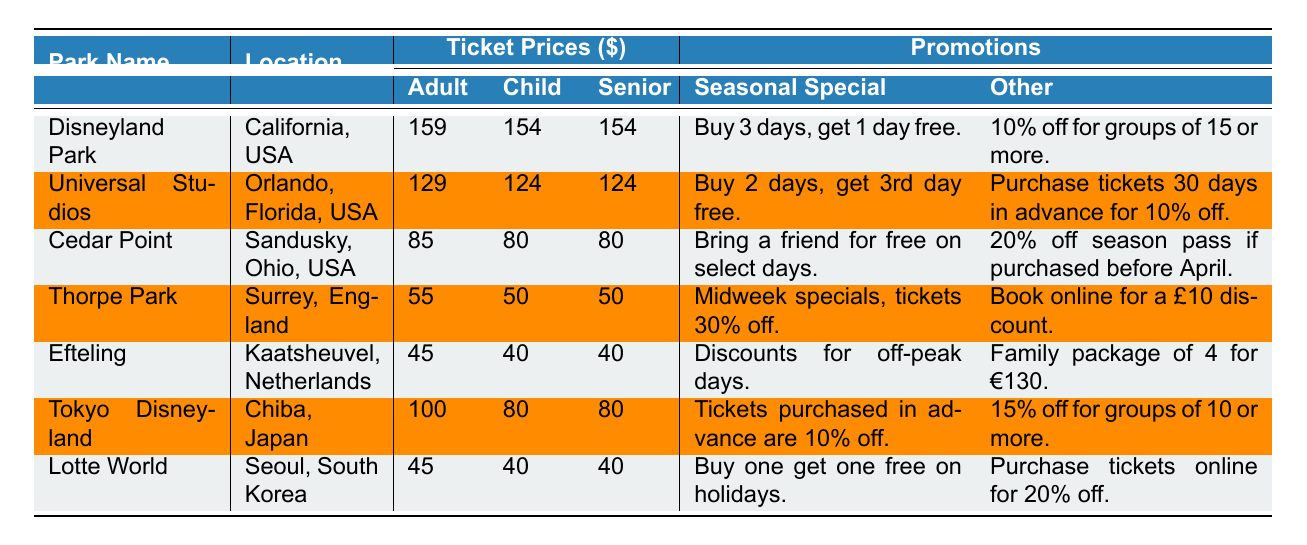What is the highest ticket price for an adult ticket? By looking at the column for adult ticket prices, Disneyland Park has the highest price of $159.
Answer: $159 Which park offers a seasonal special that allows you to buy two days and get a third day free? The table shows that Universal Studios has a seasonal special for buying two days and getting a third day free.
Answer: Universal Studios What is the combined ticket price for an adult and a child at Cedar Point? Cedar Point's adult ticket price is $85, and the child ticket price is $80. Adding these two amounts ($85 + $80) gives a total of $165.
Answer: $165 Is there a promotion for seniors at Lotte World? The table indicates that Lotte World has not specified any promotion specifically for seniors.
Answer: No Which park offers the most discounts for advance purchases? Analyzing the promotions for each park, Universal Studios and Tokyo Disneyland both have promotions related to advance purchases, but Universal Studios also includes early bird discounts for 30 days in advance, making it the park with the most associated discounts.
Answer: Universal Studios What is the total ticket price for a family of four (2 adults and 2 children) at Efteling? Efteling charges $45 for adults and $40 for children. Thus, the total ticket price is calculated as (2 * $45) + (2 * $40) = $90 + $80 = $170.
Answer: $170 Which park has the lowest combined ticket price for an adult and senior? The lowest ticket prices for adult and senior at Thorpe Park are $55 and $50 respectively. Adding these gives $55 + $50 = $105, which is lower than other parks' combinations.
Answer: Thorpe Park Does Tokyo Disneyland provide any group discounts? Yes, the table mentions that Tokyo Disneyland offers a 15% discount for groups of 10 or more.
Answer: Yes Which park located in the Netherlands offers discounts for off-peak days? Efteling, located in Kaatsheuvel, Netherlands, provides discounts for off-peak days as indicated in the promotions.
Answer: Efteling Compute the average ticket price for a child across all parks. The child prices are as follows: $154, $124, $80, $50, $40, $80, and $40. Summing these gives $154 + $124 + $80 + $50 + $40 + $80 + $40 = $568, and with 7 parks, the average is $568 / 7 = approximately $81.14.
Answer: $81.14 